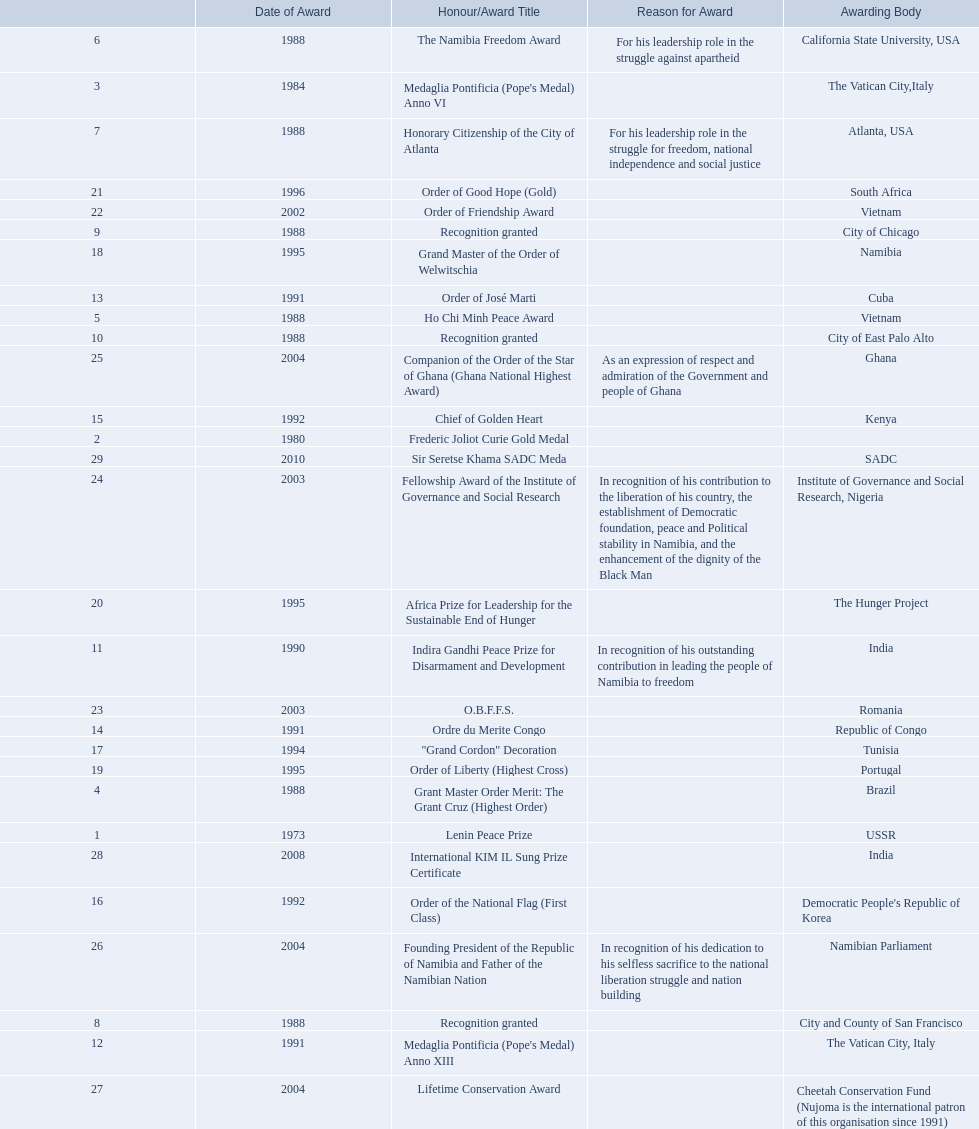What awards has sam nujoma been awarded? Lenin Peace Prize, Frederic Joliot Curie Gold Medal, Medaglia Pontificia (Pope's Medal) Anno VI, Grant Master Order Merit: The Grant Cruz (Highest Order), Ho Chi Minh Peace Award, The Namibia Freedom Award, Honorary Citizenship of the City of Atlanta, Recognition granted, Recognition granted, Recognition granted, Indira Gandhi Peace Prize for Disarmament and Development, Medaglia Pontificia (Pope's Medal) Anno XIII, Order of José Marti, Ordre du Merite Congo, Chief of Golden Heart, Order of the National Flag (First Class), "Grand Cordon" Decoration, Grand Master of the Order of Welwitschia, Order of Liberty (Highest Cross), Africa Prize for Leadership for the Sustainable End of Hunger, Order of Good Hope (Gold), Order of Friendship Award, O.B.F.F.S., Fellowship Award of the Institute of Governance and Social Research, Companion of the Order of the Star of Ghana (Ghana National Highest Award), Founding President of the Republic of Namibia and Father of the Namibian Nation, Lifetime Conservation Award, International KIM IL Sung Prize Certificate, Sir Seretse Khama SADC Meda. By which awarding body did sam nujoma receive the o.b.f.f.s award? Romania. 